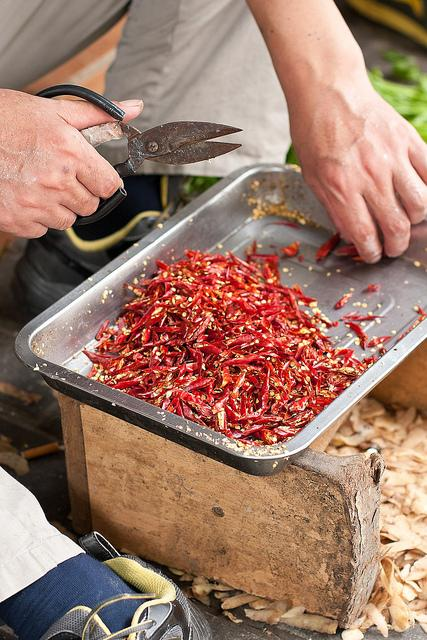Which is widely used in many cuisines as a spice to add pungent 'heat' to dishes?

Choices:
A) cucumber
B) capsicum
C) melon
D) chilies chilies 